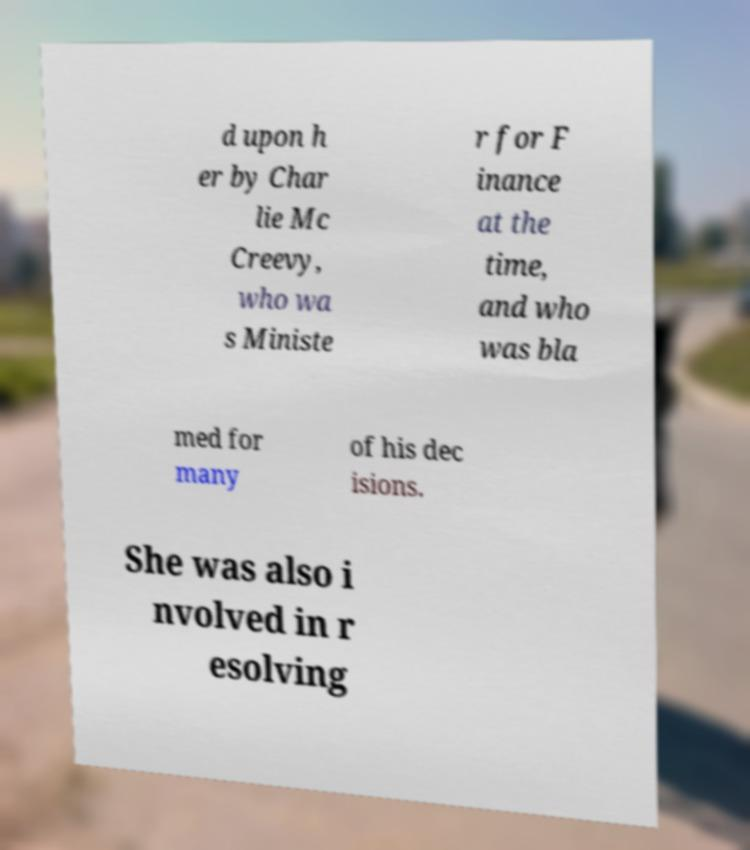There's text embedded in this image that I need extracted. Can you transcribe it verbatim? d upon h er by Char lie Mc Creevy, who wa s Ministe r for F inance at the time, and who was bla med for many of his dec isions. She was also i nvolved in r esolving 